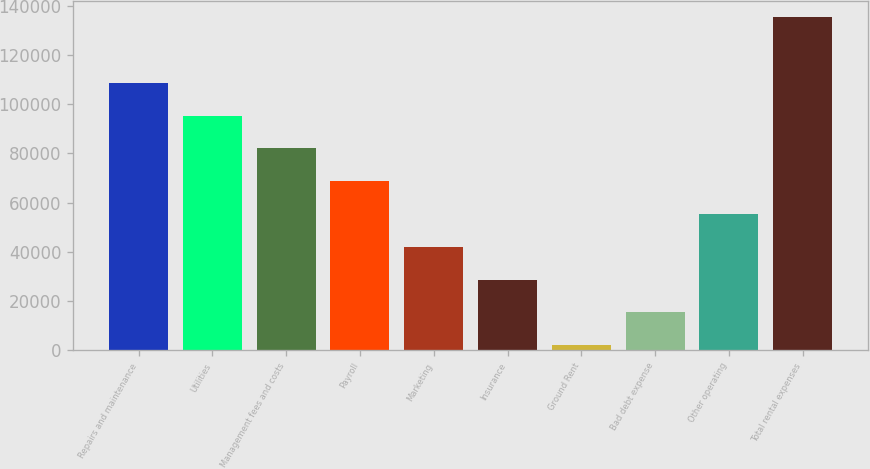<chart> <loc_0><loc_0><loc_500><loc_500><bar_chart><fcel>Repairs and maintenance<fcel>Utilities<fcel>Management fees and costs<fcel>Payroll<fcel>Marketing<fcel>Insurance<fcel>Ground Rent<fcel>Bad debt expense<fcel>Other operating<fcel>Total rental expenses<nl><fcel>108724<fcel>95377.5<fcel>82031<fcel>68684.5<fcel>41991.5<fcel>28645<fcel>1952<fcel>15298.5<fcel>55338<fcel>135417<nl></chart> 